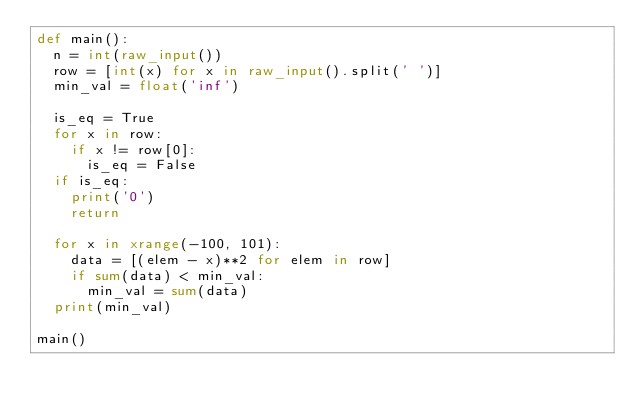<code> <loc_0><loc_0><loc_500><loc_500><_Python_>def main():
  n = int(raw_input())
  row = [int(x) for x in raw_input().split(' ')]
  min_val = float('inf')
  
  is_eq = True
  for x in row:
    if x != row[0]:
      is_eq = False
  if is_eq:
    print('0')
    return
  
  for x in xrange(-100, 101):
    data = [(elem - x)**2 for elem in row]
    if sum(data) < min_val:
      min_val = sum(data)
  print(min_val)

main()
</code> 